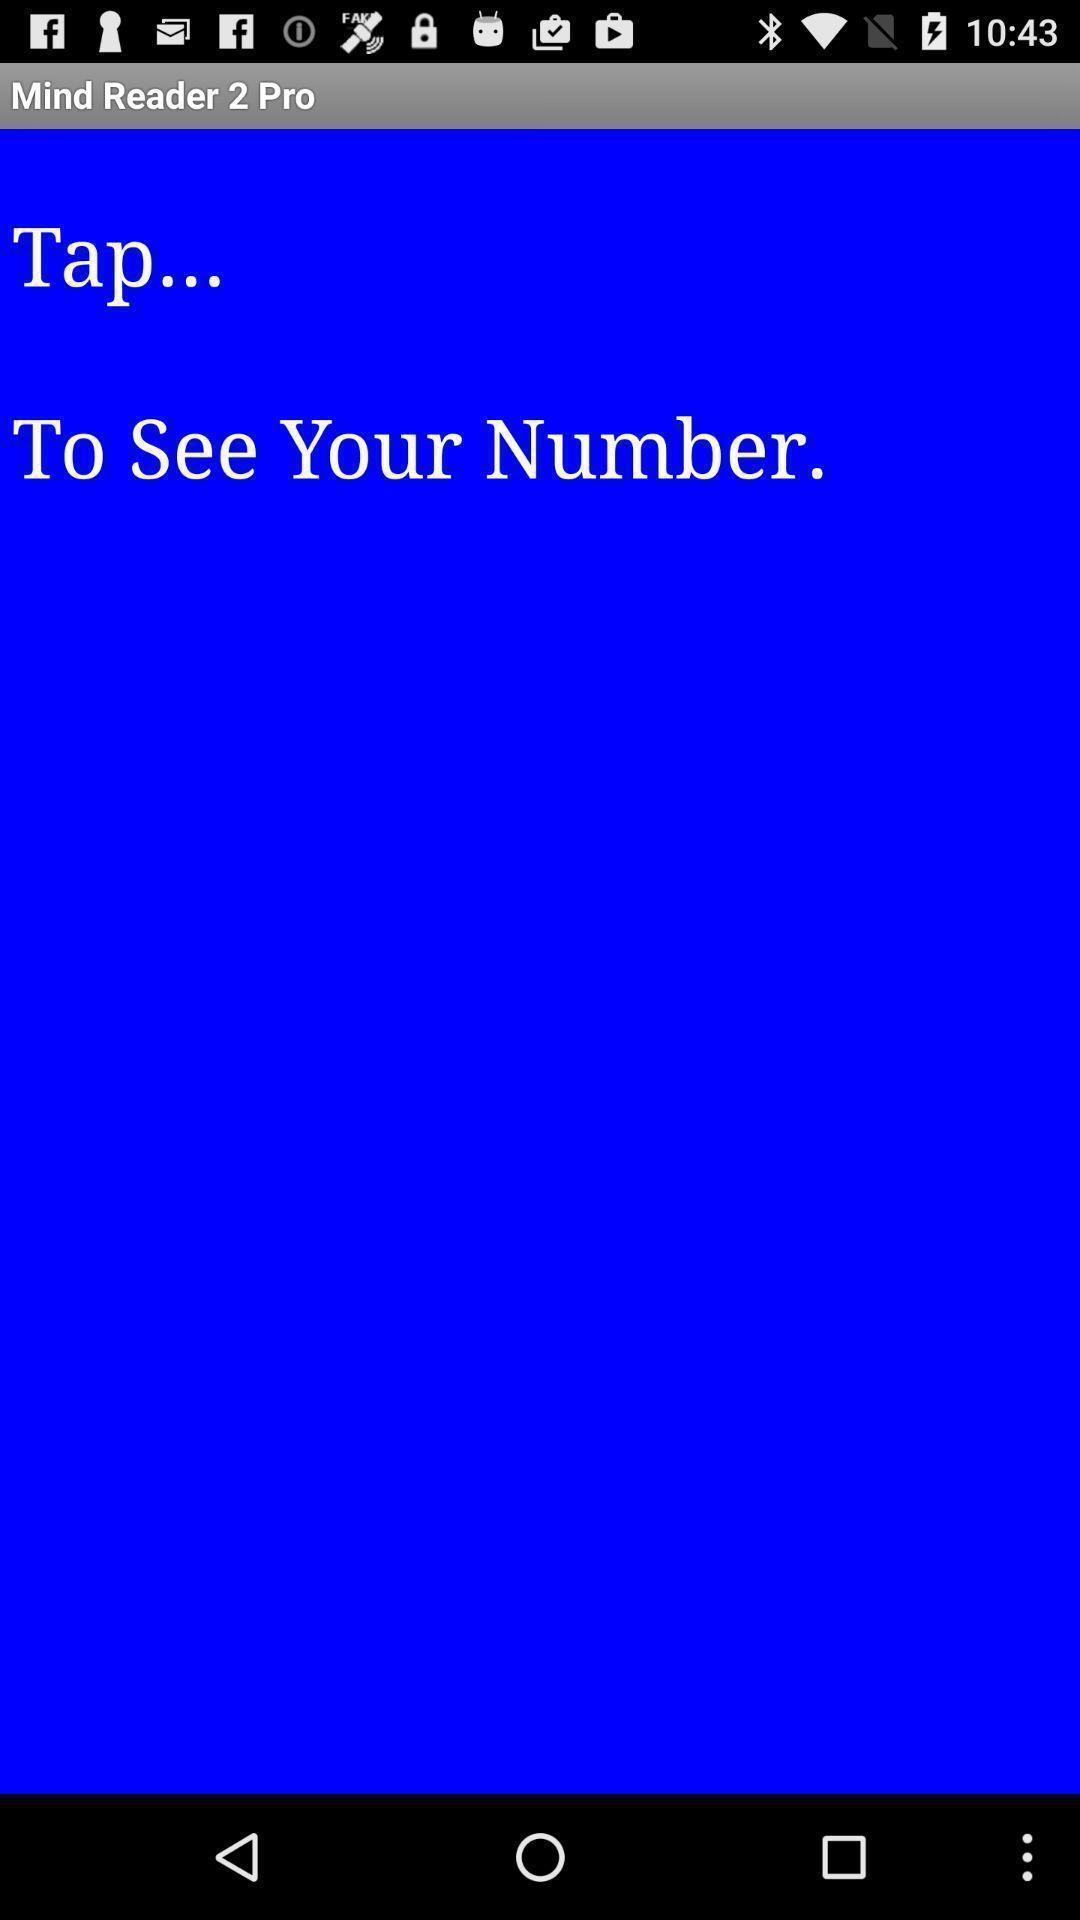Summarize the information in this screenshot. Screen shows mind reader 2 pro. 